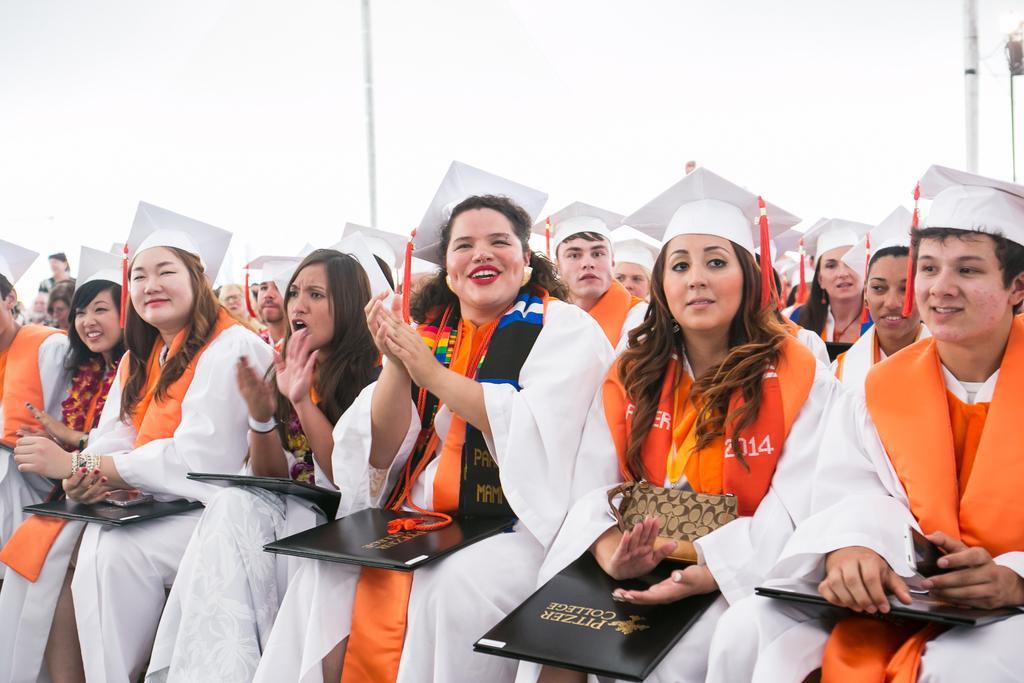Please provide a concise description of this image. People are seated wearing white hats and graduation dresses which are white and orange dresses. They are holding files and there are poles at the back. 